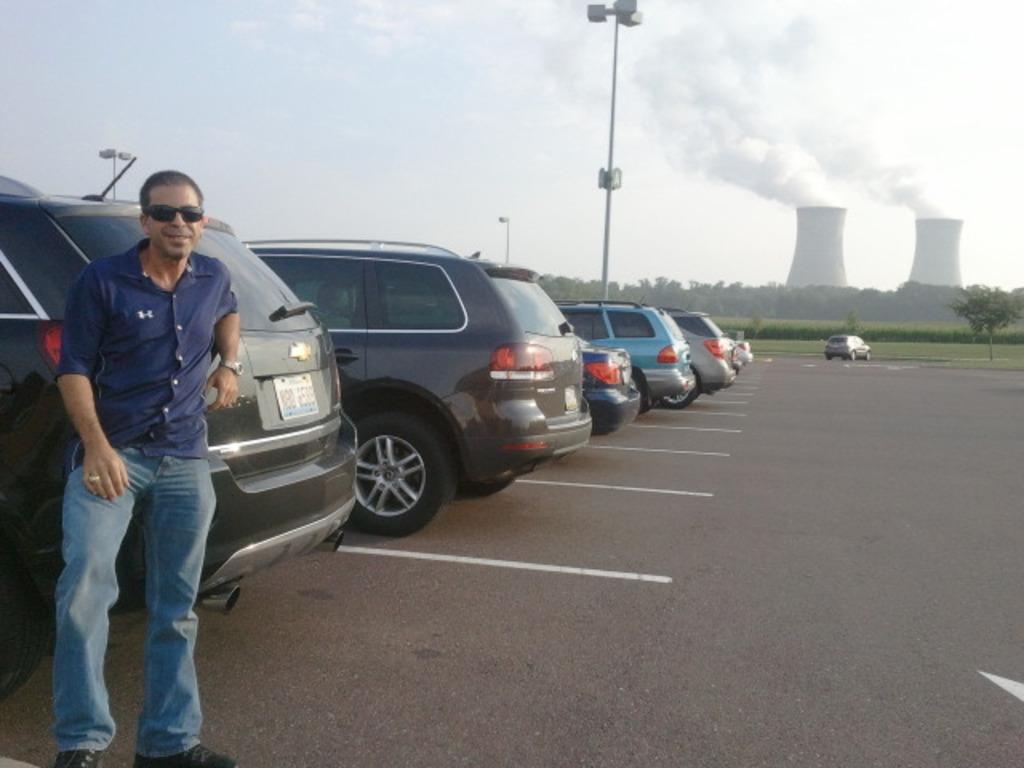Please provide a concise description of this image. There is a person wearing blue dress is standing and leaning on a car behind him and there are few other cars beside it and there are trees and some other objects in the background. 